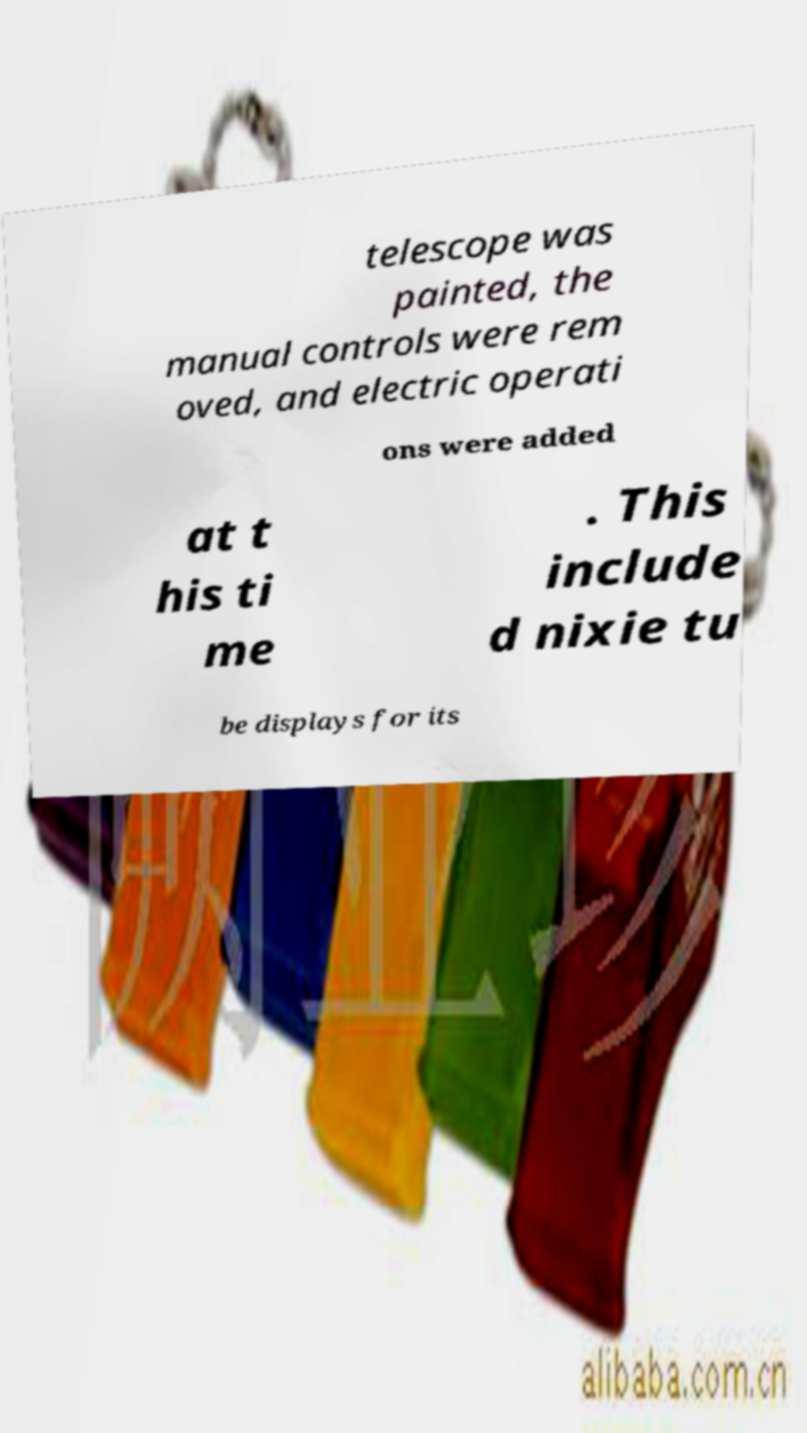I need the written content from this picture converted into text. Can you do that? telescope was painted, the manual controls were rem oved, and electric operati ons were added at t his ti me . This include d nixie tu be displays for its 